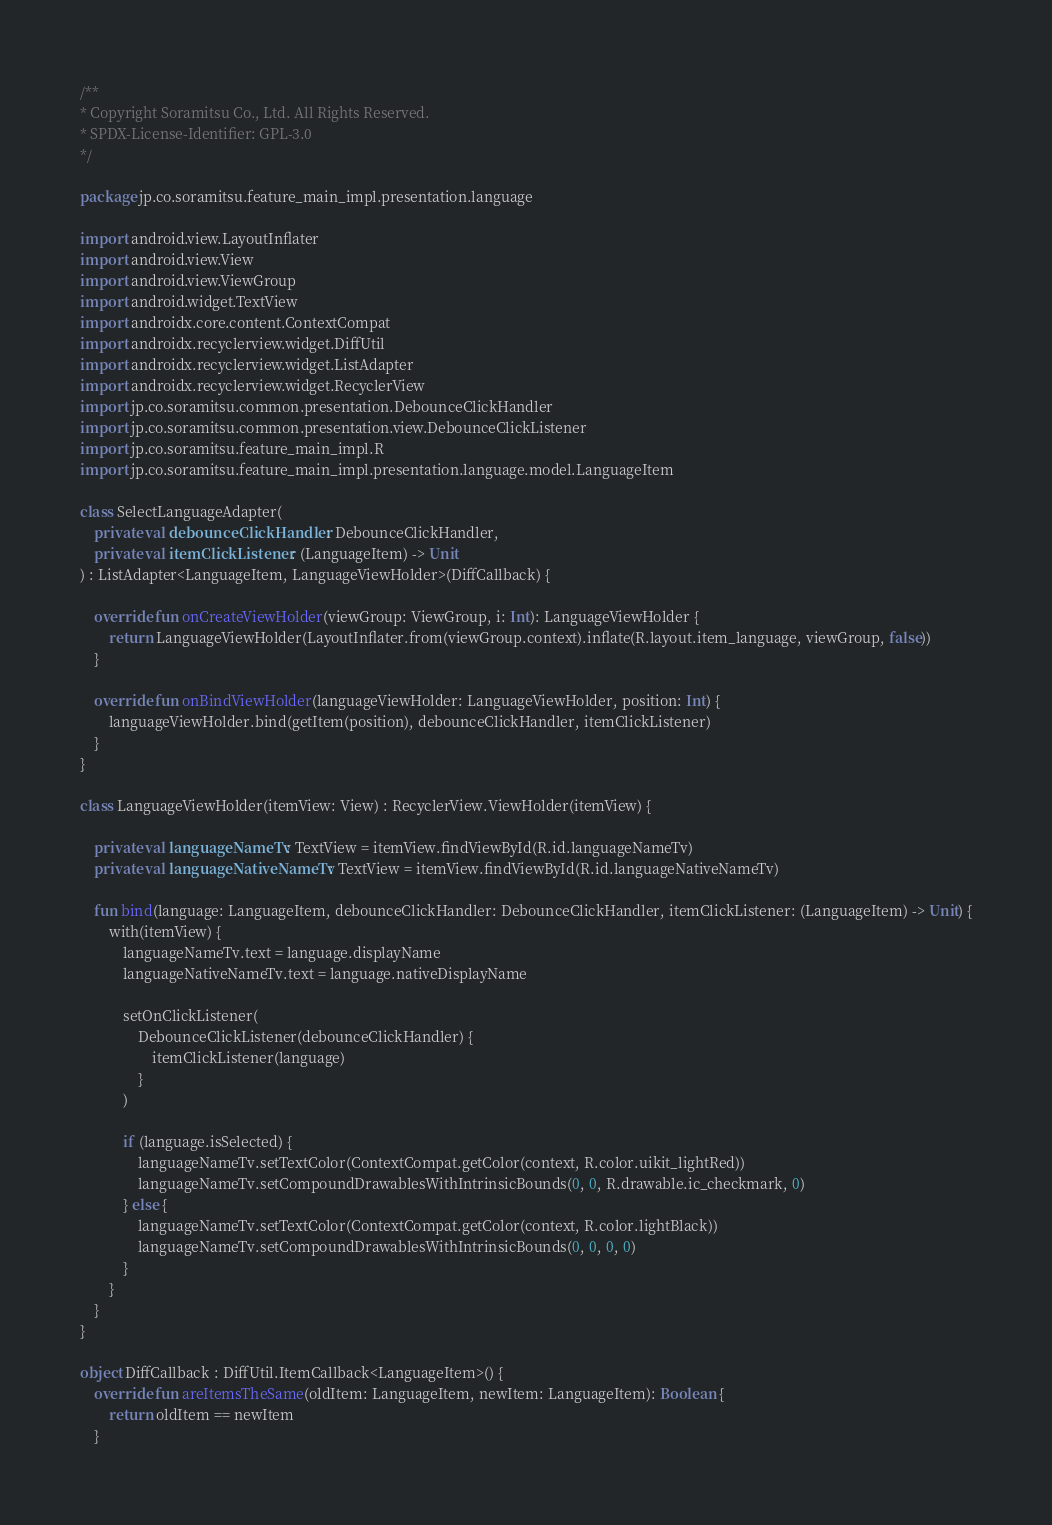<code> <loc_0><loc_0><loc_500><loc_500><_Kotlin_>/**
* Copyright Soramitsu Co., Ltd. All Rights Reserved.
* SPDX-License-Identifier: GPL-3.0
*/

package jp.co.soramitsu.feature_main_impl.presentation.language

import android.view.LayoutInflater
import android.view.View
import android.view.ViewGroup
import android.widget.TextView
import androidx.core.content.ContextCompat
import androidx.recyclerview.widget.DiffUtil
import androidx.recyclerview.widget.ListAdapter
import androidx.recyclerview.widget.RecyclerView
import jp.co.soramitsu.common.presentation.DebounceClickHandler
import jp.co.soramitsu.common.presentation.view.DebounceClickListener
import jp.co.soramitsu.feature_main_impl.R
import jp.co.soramitsu.feature_main_impl.presentation.language.model.LanguageItem

class SelectLanguageAdapter(
    private val debounceClickHandler: DebounceClickHandler,
    private val itemClickListener: (LanguageItem) -> Unit
) : ListAdapter<LanguageItem, LanguageViewHolder>(DiffCallback) {

    override fun onCreateViewHolder(viewGroup: ViewGroup, i: Int): LanguageViewHolder {
        return LanguageViewHolder(LayoutInflater.from(viewGroup.context).inflate(R.layout.item_language, viewGroup, false))
    }

    override fun onBindViewHolder(languageViewHolder: LanguageViewHolder, position: Int) {
        languageViewHolder.bind(getItem(position), debounceClickHandler, itemClickListener)
    }
}

class LanguageViewHolder(itemView: View) : RecyclerView.ViewHolder(itemView) {

    private val languageNameTv: TextView = itemView.findViewById(R.id.languageNameTv)
    private val languageNativeNameTv: TextView = itemView.findViewById(R.id.languageNativeNameTv)

    fun bind(language: LanguageItem, debounceClickHandler: DebounceClickHandler, itemClickListener: (LanguageItem) -> Unit) {
        with(itemView) {
            languageNameTv.text = language.displayName
            languageNativeNameTv.text = language.nativeDisplayName

            setOnClickListener(
                DebounceClickListener(debounceClickHandler) {
                    itemClickListener(language)
                }
            )

            if (language.isSelected) {
                languageNameTv.setTextColor(ContextCompat.getColor(context, R.color.uikit_lightRed))
                languageNameTv.setCompoundDrawablesWithIntrinsicBounds(0, 0, R.drawable.ic_checkmark, 0)
            } else {
                languageNameTv.setTextColor(ContextCompat.getColor(context, R.color.lightBlack))
                languageNameTv.setCompoundDrawablesWithIntrinsicBounds(0, 0, 0, 0)
            }
        }
    }
}

object DiffCallback : DiffUtil.ItemCallback<LanguageItem>() {
    override fun areItemsTheSame(oldItem: LanguageItem, newItem: LanguageItem): Boolean {
        return oldItem == newItem
    }
</code> 